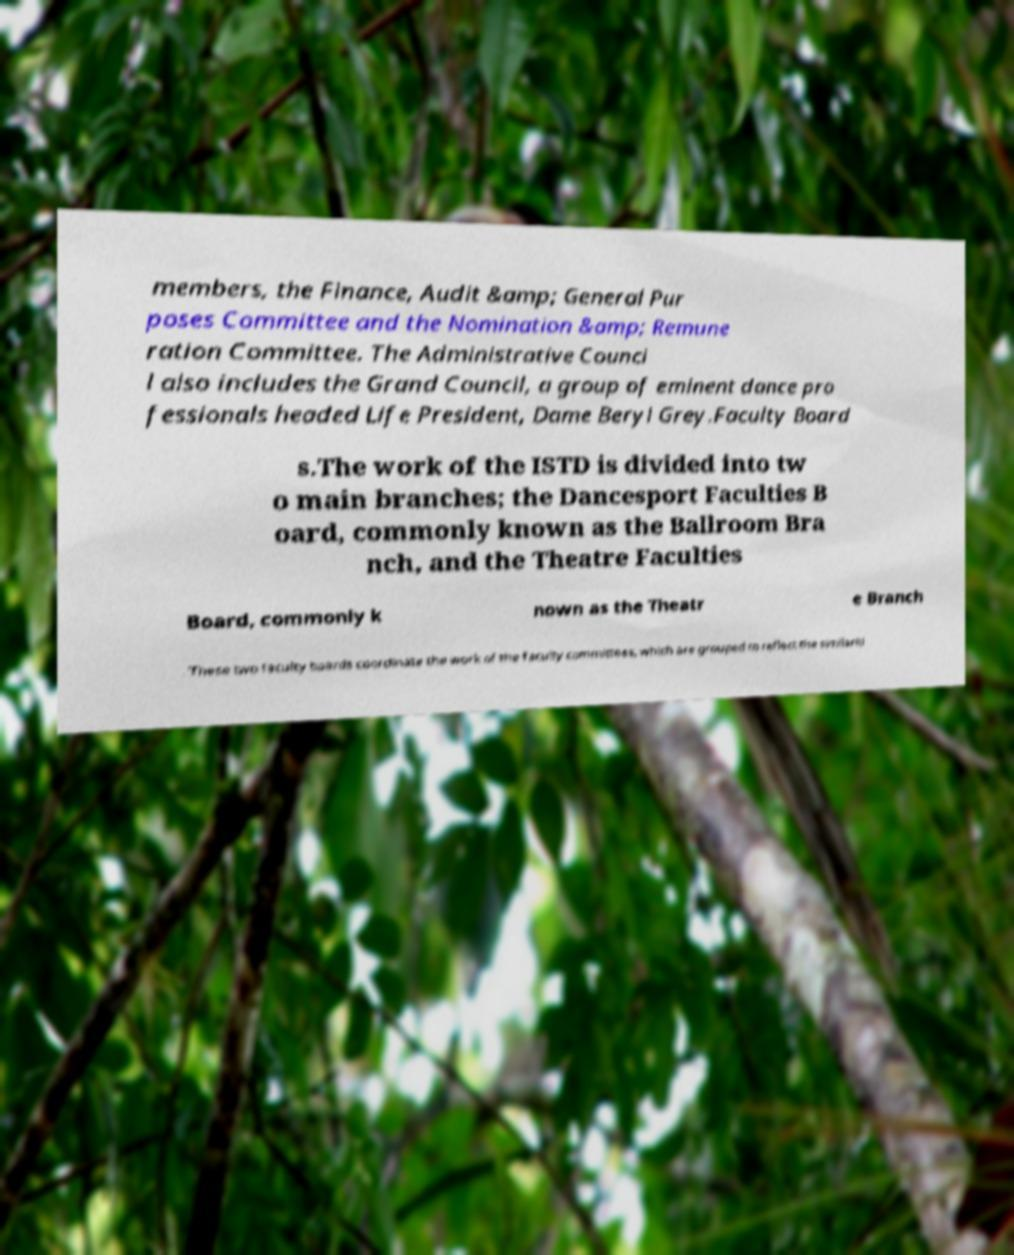Please identify and transcribe the text found in this image. members, the Finance, Audit &amp; General Pur poses Committee and the Nomination &amp; Remune ration Committee. The Administrative Counci l also includes the Grand Council, a group of eminent dance pro fessionals headed Life President, Dame Beryl Grey.Faculty Board s.The work of the ISTD is divided into tw o main branches; the Dancesport Faculties B oard, commonly known as the Ballroom Bra nch, and the Theatre Faculties Board, commonly k nown as the Theatr e Branch . These two faculty boards coordinate the work of the faculty committees, which are grouped to reflect the similariti 